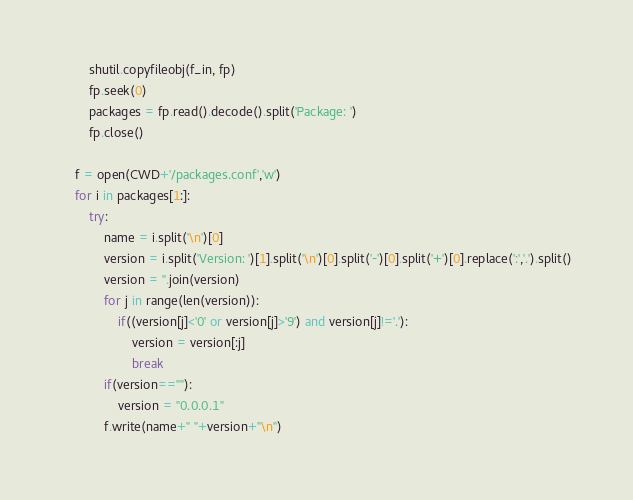<code> <loc_0><loc_0><loc_500><loc_500><_Python_>		shutil.copyfileobj(f_in, fp)
		fp.seek(0)
		packages = fp.read().decode().split('Package: ')
		fp.close()

	f = open(CWD+'/packages.conf','w')
	for i in packages[1:]:
		try:
			name = i.split('\n')[0]
			version = i.split('Version: ')[1].split('\n')[0].split('-')[0].split('+')[0].replace(':','.').split()
			version = ''.join(version)
			for j in range(len(version)):
				if((version[j]<'0' or version[j]>'9') and version[j]!='.'):
					version = version[:j]
					break
			if(version==""):
				version = "0.0.0.1"
			f.write(name+" "+version+"\n")</code> 